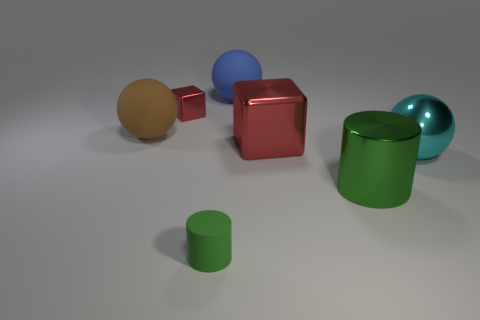There is a big blue thing that is made of the same material as the small cylinder; what shape is it?
Offer a terse response. Sphere. Are there any other things that are the same color as the tiny metallic cube?
Offer a terse response. Yes. There is a red metal thing to the left of the cylinder that is left of the big red object; how many matte balls are on the right side of it?
Offer a very short reply. 1. What number of green things are either big shiny balls or big things?
Your response must be concise. 1. Does the blue ball have the same size as the green cylinder that is on the right side of the blue ball?
Provide a succinct answer. Yes. What is the material of the other small green object that is the same shape as the green metallic object?
Your answer should be very brief. Rubber. How many other objects are there of the same size as the brown rubber ball?
Your answer should be very brief. 4. The large blue object to the right of the block that is behind the large rubber sphere that is to the left of the blue thing is what shape?
Offer a very short reply. Sphere. There is a rubber thing that is both behind the tiny green object and in front of the tiny block; what shape is it?
Your response must be concise. Sphere. What number of things are either brown matte balls or large metal things on the left side of the cyan object?
Ensure brevity in your answer.  3. 